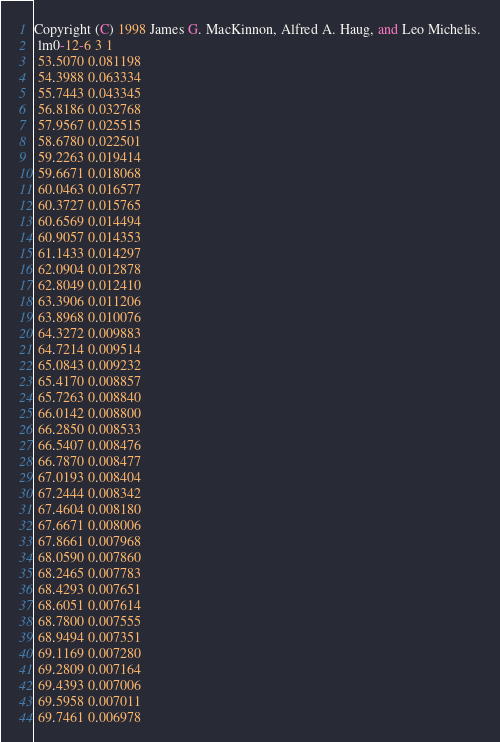<code> <loc_0><loc_0><loc_500><loc_500><_SQL_>Copyright (C) 1998 James G. MacKinnon, Alfred A. Haug, and Leo Michelis.
 lm0-12-6 3 1
 53.5070 0.081198
 54.3988 0.063334
 55.7443 0.043345
 56.8186 0.032768
 57.9567 0.025515
 58.6780 0.022501
 59.2263 0.019414
 59.6671 0.018068
 60.0463 0.016577
 60.3727 0.015765
 60.6569 0.014494
 60.9057 0.014353
 61.1433 0.014297
 62.0904 0.012878
 62.8049 0.012410
 63.3906 0.011206
 63.8968 0.010076
 64.3272 0.009883
 64.7214 0.009514
 65.0843 0.009232
 65.4170 0.008857
 65.7263 0.008840
 66.0142 0.008800
 66.2850 0.008533
 66.5407 0.008476
 66.7870 0.008477
 67.0193 0.008404
 67.2444 0.008342
 67.4604 0.008180
 67.6671 0.008006
 67.8661 0.007968
 68.0590 0.007860
 68.2465 0.007783
 68.4293 0.007651
 68.6051 0.007614
 68.7800 0.007555
 68.9494 0.007351
 69.1169 0.007280
 69.2809 0.007164
 69.4393 0.007006
 69.5958 0.007011
 69.7461 0.006978</code> 